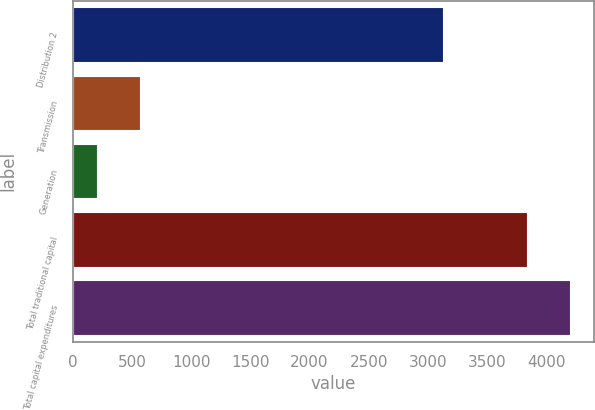<chart> <loc_0><loc_0><loc_500><loc_500><bar_chart><fcel>Distribution 2<fcel>Transmission<fcel>Generation<fcel>Total traditional capital<fcel>Total capital expenditures<nl><fcel>3131<fcel>566.2<fcel>203<fcel>3835<fcel>4198.2<nl></chart> 